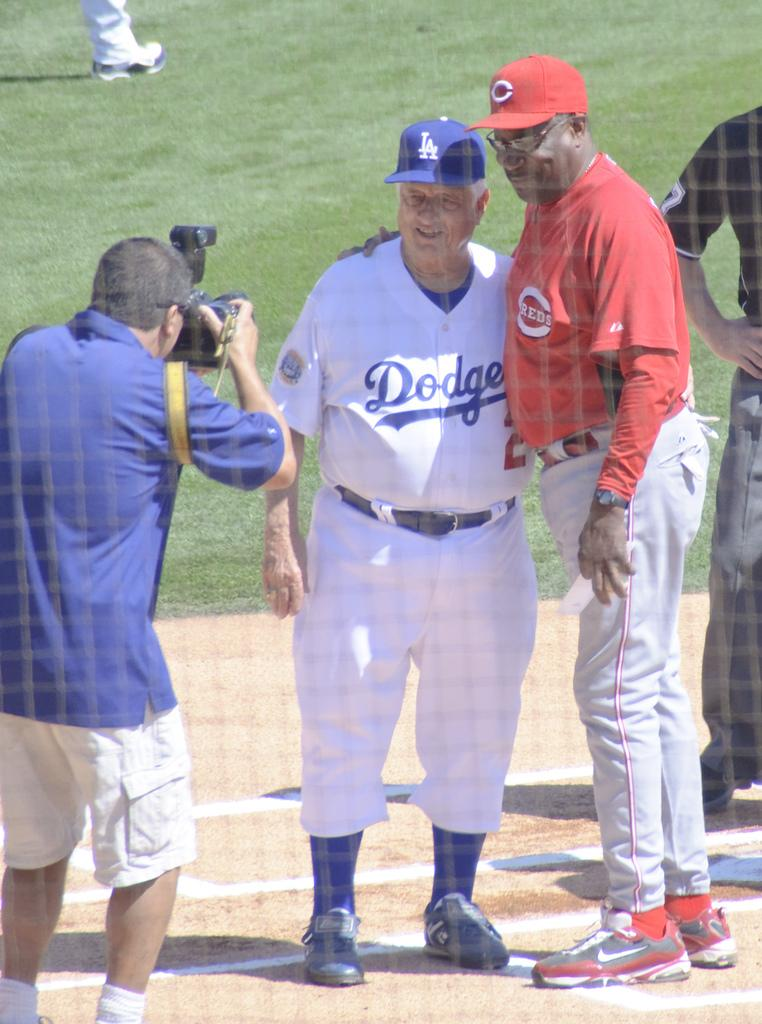<image>
Relay a brief, clear account of the picture shown. A man in a Dodgers uniform poses for a photo with a man in a Reds uniform. 